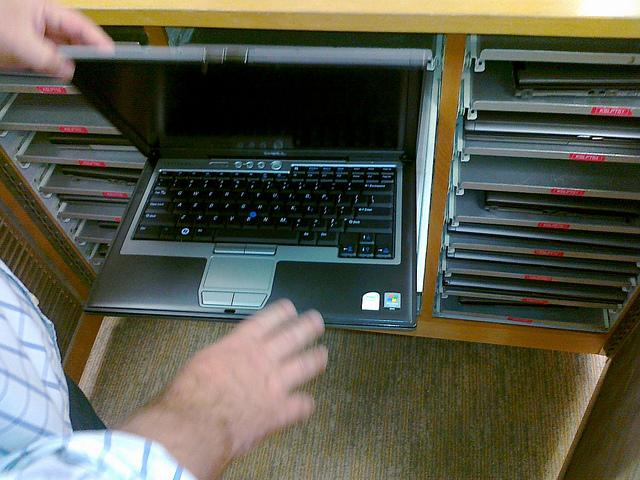What word is associated with the item the person is touching? Please explain your reasoning. space bar. Space bar is the only choice that is found on a computer. 